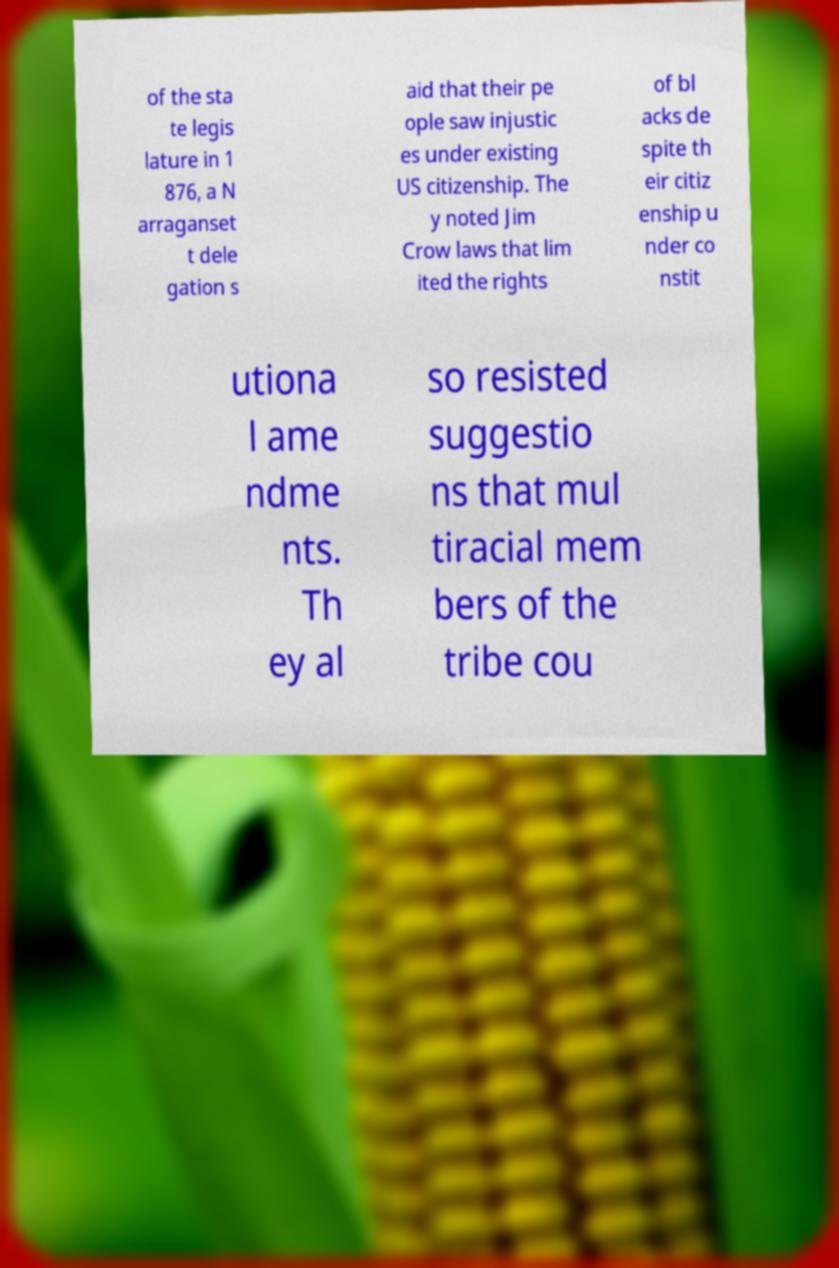Please read and relay the text visible in this image. What does it say? of the sta te legis lature in 1 876, a N arraganset t dele gation s aid that their pe ople saw injustic es under existing US citizenship. The y noted Jim Crow laws that lim ited the rights of bl acks de spite th eir citiz enship u nder co nstit utiona l ame ndme nts. Th ey al so resisted suggestio ns that mul tiracial mem bers of the tribe cou 